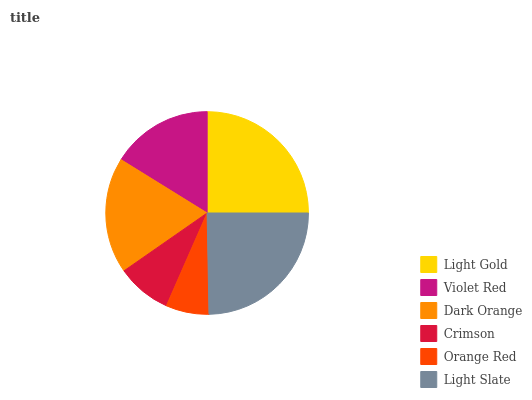Is Orange Red the minimum?
Answer yes or no. Yes. Is Light Gold the maximum?
Answer yes or no. Yes. Is Violet Red the minimum?
Answer yes or no. No. Is Violet Red the maximum?
Answer yes or no. No. Is Light Gold greater than Violet Red?
Answer yes or no. Yes. Is Violet Red less than Light Gold?
Answer yes or no. Yes. Is Violet Red greater than Light Gold?
Answer yes or no. No. Is Light Gold less than Violet Red?
Answer yes or no. No. Is Dark Orange the high median?
Answer yes or no. Yes. Is Violet Red the low median?
Answer yes or no. Yes. Is Crimson the high median?
Answer yes or no. No. Is Light Slate the low median?
Answer yes or no. No. 